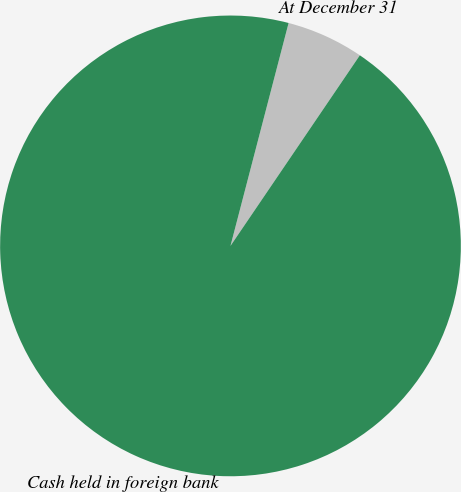Convert chart to OTSL. <chart><loc_0><loc_0><loc_500><loc_500><pie_chart><fcel>At December 31<fcel>Cash held in foreign bank<nl><fcel>5.43%<fcel>94.57%<nl></chart> 